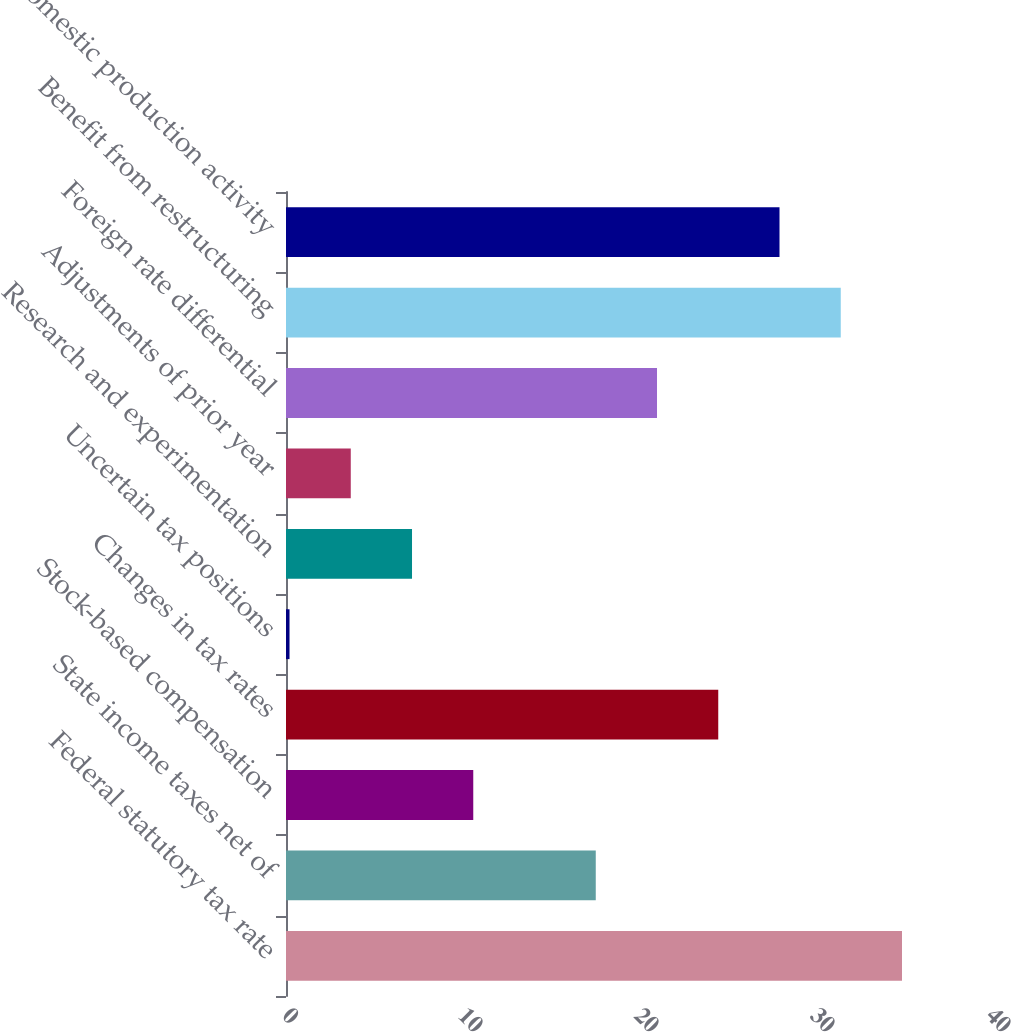Convert chart to OTSL. <chart><loc_0><loc_0><loc_500><loc_500><bar_chart><fcel>Federal statutory tax rate<fcel>State income taxes net of<fcel>Stock-based compensation<fcel>Changes in tax rates<fcel>Uncertain tax positions<fcel>Research and experimentation<fcel>Adjustments of prior year<fcel>Foreign rate differential<fcel>Benefit from restructuring<fcel>Domestic production activity<nl><fcel>35<fcel>17.6<fcel>10.64<fcel>24.56<fcel>0.2<fcel>7.16<fcel>3.68<fcel>21.08<fcel>31.52<fcel>28.04<nl></chart> 